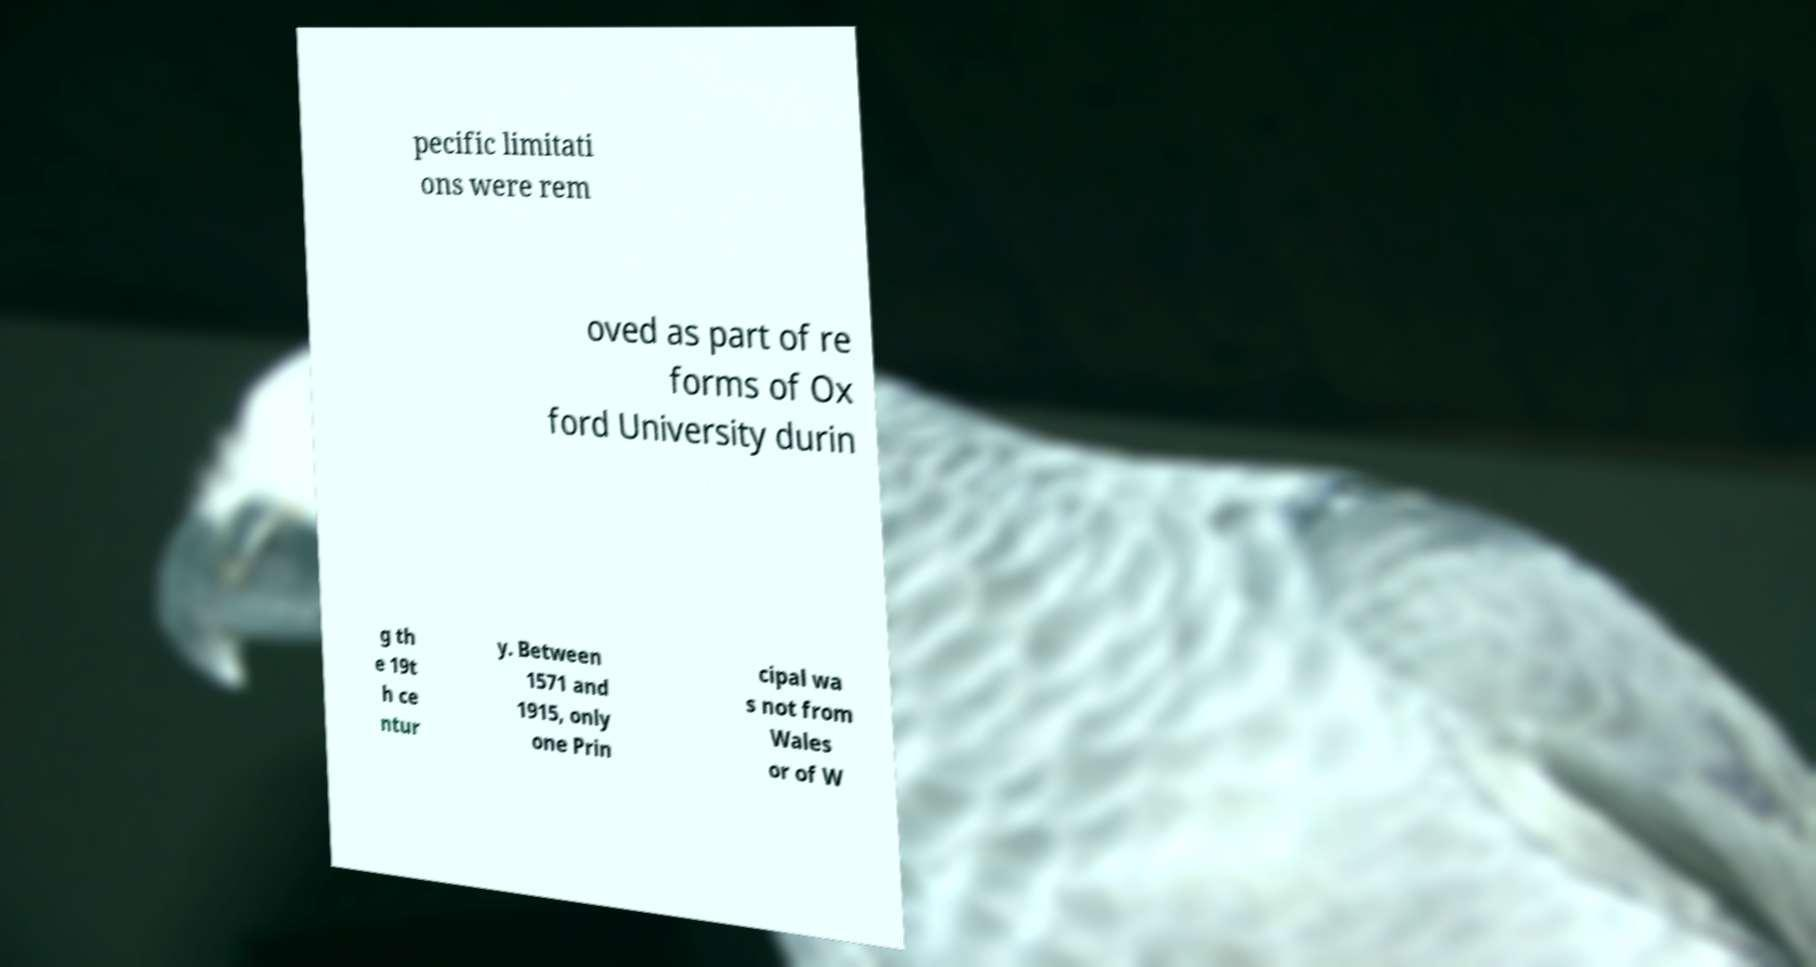What messages or text are displayed in this image? I need them in a readable, typed format. pecific limitati ons were rem oved as part of re forms of Ox ford University durin g th e 19t h ce ntur y. Between 1571 and 1915, only one Prin cipal wa s not from Wales or of W 